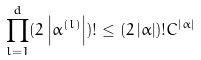Convert formula to latex. <formula><loc_0><loc_0><loc_500><loc_500>\prod _ { l = 1 } ^ { d } ( 2 \left | \alpha ^ { ( l ) } \right | ) ! \leq ( 2 \left | \alpha \right | ) ! C ^ { \left | \alpha \right | }</formula> 